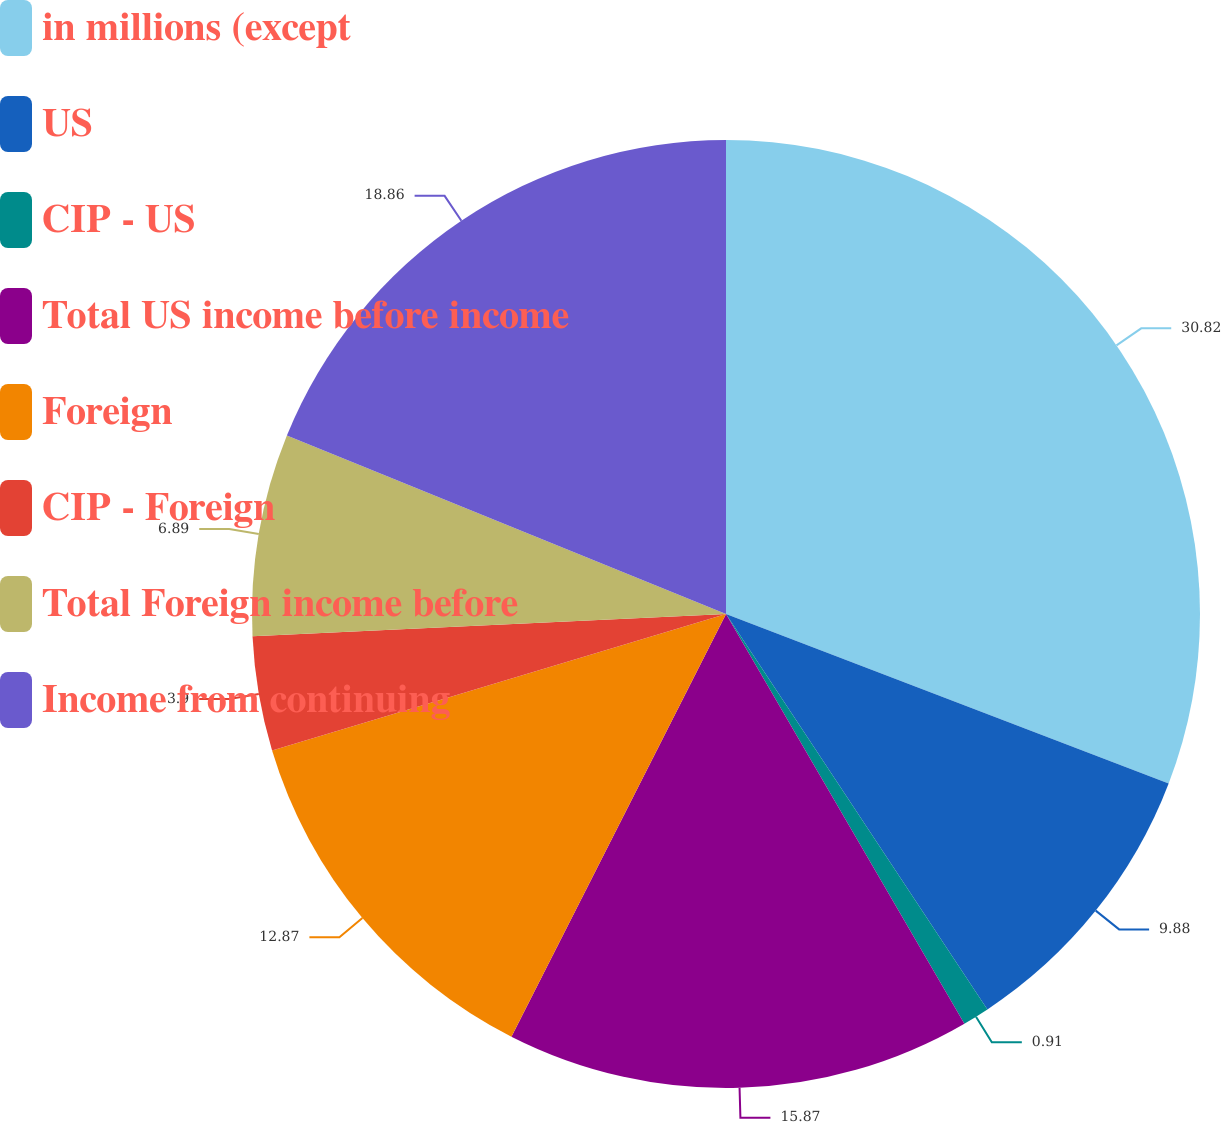Convert chart. <chart><loc_0><loc_0><loc_500><loc_500><pie_chart><fcel>in millions (except<fcel>US<fcel>CIP - US<fcel>Total US income before income<fcel>Foreign<fcel>CIP - Foreign<fcel>Total Foreign income before<fcel>Income from continuing<nl><fcel>30.81%<fcel>9.88%<fcel>0.91%<fcel>15.86%<fcel>12.87%<fcel>3.9%<fcel>6.89%<fcel>18.85%<nl></chart> 